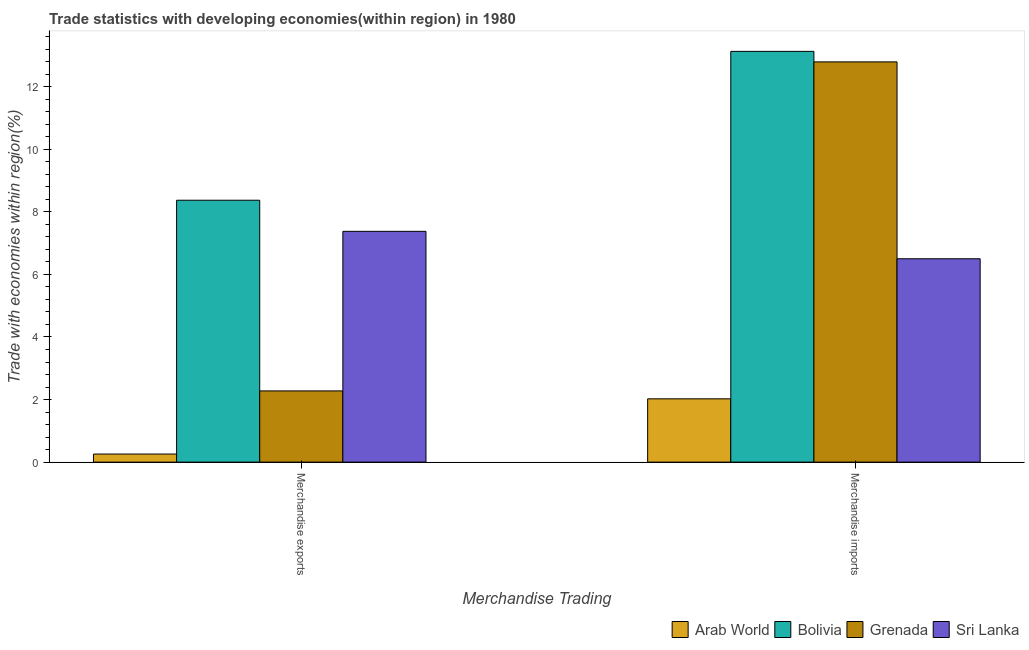How many groups of bars are there?
Your answer should be very brief. 2. How many bars are there on the 1st tick from the left?
Make the answer very short. 4. How many bars are there on the 1st tick from the right?
Make the answer very short. 4. What is the label of the 1st group of bars from the left?
Your answer should be compact. Merchandise exports. What is the merchandise exports in Grenada?
Make the answer very short. 2.28. Across all countries, what is the maximum merchandise exports?
Your answer should be compact. 8.37. Across all countries, what is the minimum merchandise imports?
Provide a short and direct response. 2.02. In which country was the merchandise imports maximum?
Make the answer very short. Bolivia. In which country was the merchandise exports minimum?
Your response must be concise. Arab World. What is the total merchandise exports in the graph?
Offer a terse response. 18.28. What is the difference between the merchandise exports in Bolivia and that in Sri Lanka?
Offer a terse response. 0.99. What is the difference between the merchandise exports in Grenada and the merchandise imports in Arab World?
Your answer should be compact. 0.25. What is the average merchandise exports per country?
Give a very brief answer. 4.57. What is the difference between the merchandise imports and merchandise exports in Sri Lanka?
Your answer should be compact. -0.88. In how many countries, is the merchandise imports greater than 6.4 %?
Provide a succinct answer. 3. What is the ratio of the merchandise exports in Grenada to that in Bolivia?
Ensure brevity in your answer.  0.27. Is the merchandise imports in Bolivia less than that in Grenada?
Make the answer very short. No. In how many countries, is the merchandise imports greater than the average merchandise imports taken over all countries?
Your answer should be compact. 2. What does the 3rd bar from the left in Merchandise imports represents?
Make the answer very short. Grenada. What does the 3rd bar from the right in Merchandise exports represents?
Offer a very short reply. Bolivia. How many bars are there?
Your answer should be very brief. 8. Are all the bars in the graph horizontal?
Provide a short and direct response. No. Does the graph contain any zero values?
Ensure brevity in your answer.  No. Where does the legend appear in the graph?
Provide a succinct answer. Bottom right. How many legend labels are there?
Provide a short and direct response. 4. What is the title of the graph?
Ensure brevity in your answer.  Trade statistics with developing economies(within region) in 1980. What is the label or title of the X-axis?
Your response must be concise. Merchandise Trading. What is the label or title of the Y-axis?
Offer a terse response. Trade with economies within region(%). What is the Trade with economies within region(%) in Arab World in Merchandise exports?
Your answer should be compact. 0.26. What is the Trade with economies within region(%) in Bolivia in Merchandise exports?
Provide a short and direct response. 8.37. What is the Trade with economies within region(%) of Grenada in Merchandise exports?
Provide a succinct answer. 2.28. What is the Trade with economies within region(%) of Sri Lanka in Merchandise exports?
Your answer should be compact. 7.38. What is the Trade with economies within region(%) of Arab World in Merchandise imports?
Your answer should be compact. 2.02. What is the Trade with economies within region(%) of Bolivia in Merchandise imports?
Your answer should be very brief. 13.13. What is the Trade with economies within region(%) of Grenada in Merchandise imports?
Give a very brief answer. 12.79. What is the Trade with economies within region(%) in Sri Lanka in Merchandise imports?
Offer a very short reply. 6.5. Across all Merchandise Trading, what is the maximum Trade with economies within region(%) in Arab World?
Give a very brief answer. 2.02. Across all Merchandise Trading, what is the maximum Trade with economies within region(%) in Bolivia?
Ensure brevity in your answer.  13.13. Across all Merchandise Trading, what is the maximum Trade with economies within region(%) of Grenada?
Offer a very short reply. 12.79. Across all Merchandise Trading, what is the maximum Trade with economies within region(%) in Sri Lanka?
Ensure brevity in your answer.  7.38. Across all Merchandise Trading, what is the minimum Trade with economies within region(%) of Arab World?
Your answer should be compact. 0.26. Across all Merchandise Trading, what is the minimum Trade with economies within region(%) of Bolivia?
Make the answer very short. 8.37. Across all Merchandise Trading, what is the minimum Trade with economies within region(%) in Grenada?
Ensure brevity in your answer.  2.28. Across all Merchandise Trading, what is the minimum Trade with economies within region(%) in Sri Lanka?
Offer a terse response. 6.5. What is the total Trade with economies within region(%) of Arab World in the graph?
Give a very brief answer. 2.28. What is the total Trade with economies within region(%) in Bolivia in the graph?
Make the answer very short. 21.5. What is the total Trade with economies within region(%) in Grenada in the graph?
Offer a terse response. 15.07. What is the total Trade with economies within region(%) of Sri Lanka in the graph?
Ensure brevity in your answer.  13.88. What is the difference between the Trade with economies within region(%) of Arab World in Merchandise exports and that in Merchandise imports?
Offer a very short reply. -1.76. What is the difference between the Trade with economies within region(%) of Bolivia in Merchandise exports and that in Merchandise imports?
Provide a succinct answer. -4.76. What is the difference between the Trade with economies within region(%) in Grenada in Merchandise exports and that in Merchandise imports?
Offer a very short reply. -10.52. What is the difference between the Trade with economies within region(%) in Sri Lanka in Merchandise exports and that in Merchandise imports?
Your answer should be compact. 0.88. What is the difference between the Trade with economies within region(%) in Arab World in Merchandise exports and the Trade with economies within region(%) in Bolivia in Merchandise imports?
Your response must be concise. -12.87. What is the difference between the Trade with economies within region(%) of Arab World in Merchandise exports and the Trade with economies within region(%) of Grenada in Merchandise imports?
Your answer should be very brief. -12.53. What is the difference between the Trade with economies within region(%) in Arab World in Merchandise exports and the Trade with economies within region(%) in Sri Lanka in Merchandise imports?
Give a very brief answer. -6.24. What is the difference between the Trade with economies within region(%) in Bolivia in Merchandise exports and the Trade with economies within region(%) in Grenada in Merchandise imports?
Offer a very short reply. -4.42. What is the difference between the Trade with economies within region(%) of Bolivia in Merchandise exports and the Trade with economies within region(%) of Sri Lanka in Merchandise imports?
Offer a terse response. 1.87. What is the difference between the Trade with economies within region(%) in Grenada in Merchandise exports and the Trade with economies within region(%) in Sri Lanka in Merchandise imports?
Offer a very short reply. -4.22. What is the average Trade with economies within region(%) in Arab World per Merchandise Trading?
Your answer should be very brief. 1.14. What is the average Trade with economies within region(%) in Bolivia per Merchandise Trading?
Make the answer very short. 10.75. What is the average Trade with economies within region(%) of Grenada per Merchandise Trading?
Give a very brief answer. 7.53. What is the average Trade with economies within region(%) in Sri Lanka per Merchandise Trading?
Make the answer very short. 6.94. What is the difference between the Trade with economies within region(%) in Arab World and Trade with economies within region(%) in Bolivia in Merchandise exports?
Keep it short and to the point. -8.11. What is the difference between the Trade with economies within region(%) of Arab World and Trade with economies within region(%) of Grenada in Merchandise exports?
Ensure brevity in your answer.  -2.02. What is the difference between the Trade with economies within region(%) in Arab World and Trade with economies within region(%) in Sri Lanka in Merchandise exports?
Your answer should be compact. -7.12. What is the difference between the Trade with economies within region(%) of Bolivia and Trade with economies within region(%) of Grenada in Merchandise exports?
Provide a short and direct response. 6.1. What is the difference between the Trade with economies within region(%) of Grenada and Trade with economies within region(%) of Sri Lanka in Merchandise exports?
Your response must be concise. -5.1. What is the difference between the Trade with economies within region(%) of Arab World and Trade with economies within region(%) of Bolivia in Merchandise imports?
Your response must be concise. -11.11. What is the difference between the Trade with economies within region(%) of Arab World and Trade with economies within region(%) of Grenada in Merchandise imports?
Give a very brief answer. -10.77. What is the difference between the Trade with economies within region(%) of Arab World and Trade with economies within region(%) of Sri Lanka in Merchandise imports?
Make the answer very short. -4.48. What is the difference between the Trade with economies within region(%) in Bolivia and Trade with economies within region(%) in Grenada in Merchandise imports?
Provide a succinct answer. 0.34. What is the difference between the Trade with economies within region(%) of Bolivia and Trade with economies within region(%) of Sri Lanka in Merchandise imports?
Keep it short and to the point. 6.63. What is the difference between the Trade with economies within region(%) of Grenada and Trade with economies within region(%) of Sri Lanka in Merchandise imports?
Your answer should be very brief. 6.29. What is the ratio of the Trade with economies within region(%) in Arab World in Merchandise exports to that in Merchandise imports?
Make the answer very short. 0.13. What is the ratio of the Trade with economies within region(%) of Bolivia in Merchandise exports to that in Merchandise imports?
Your answer should be very brief. 0.64. What is the ratio of the Trade with economies within region(%) in Grenada in Merchandise exports to that in Merchandise imports?
Provide a short and direct response. 0.18. What is the ratio of the Trade with economies within region(%) of Sri Lanka in Merchandise exports to that in Merchandise imports?
Make the answer very short. 1.13. What is the difference between the highest and the second highest Trade with economies within region(%) in Arab World?
Give a very brief answer. 1.76. What is the difference between the highest and the second highest Trade with economies within region(%) in Bolivia?
Offer a very short reply. 4.76. What is the difference between the highest and the second highest Trade with economies within region(%) of Grenada?
Your answer should be very brief. 10.52. What is the difference between the highest and the second highest Trade with economies within region(%) in Sri Lanka?
Offer a terse response. 0.88. What is the difference between the highest and the lowest Trade with economies within region(%) in Arab World?
Provide a short and direct response. 1.76. What is the difference between the highest and the lowest Trade with economies within region(%) of Bolivia?
Offer a terse response. 4.76. What is the difference between the highest and the lowest Trade with economies within region(%) in Grenada?
Offer a terse response. 10.52. What is the difference between the highest and the lowest Trade with economies within region(%) in Sri Lanka?
Provide a succinct answer. 0.88. 